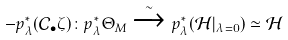Convert formula to latex. <formula><loc_0><loc_0><loc_500><loc_500>- p ^ { * } _ { \lambda } ( \mathcal { C } _ { \bullet } \zeta ) \colon p _ { \lambda } ^ { * } \Theta _ { M } \xrightarrow { \sim } p ^ { * } _ { \lambda } ( \mathcal { H } | _ { \lambda = 0 } ) \simeq \mathcal { H }</formula> 